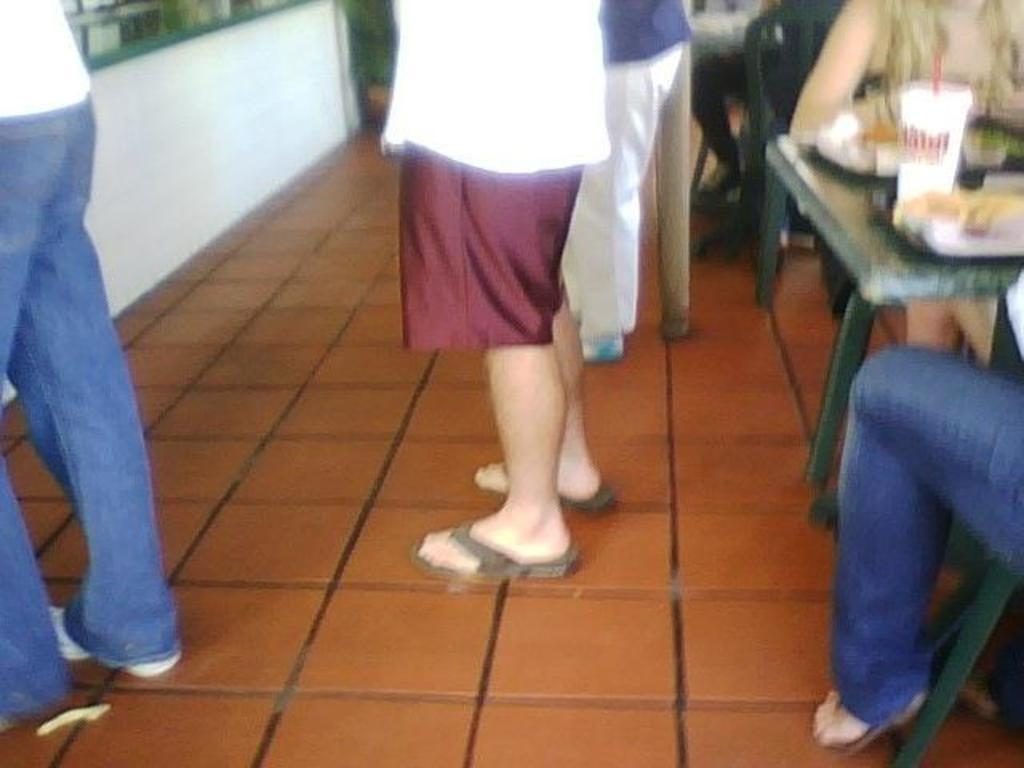How many people are present in the image? There are three persons standing in the image. What are the positions of the sitting individuals in the image? There is a woman sitting on the right side of the image, and a man sitting on the right side of the image. What object can be seen on the table in the image? A cup is visible on the table in the image. What type of instrument is the woman playing in the image? There is no instrument present in the image, and the woman is sitting, not playing anything. 